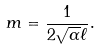Convert formula to latex. <formula><loc_0><loc_0><loc_500><loc_500>m = \frac { 1 } { 2 \sqrt { \alpha } \ell } .</formula> 